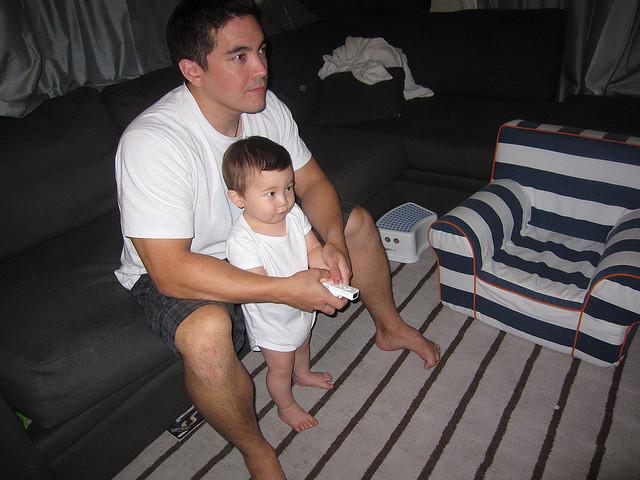What is the man and kid doing?
Keep it brief. Gaming. Is the chair wooden?
Write a very short answer. No. Is this child wearing a cap?
Be succinct. No. What are the baby and the man doing?
Write a very short answer. Playing wii. Are these people getting exercise while playing this video game?
Quick response, please. No. Is the rug striped?
Answer briefly. Yes. What does the man have in his left hand?
Write a very short answer. Controller. What are they sitting on?
Write a very short answer. Couch. Is the baby playing WII?
Short answer required. Yes. What is the person doing?
Give a very brief answer. Playing wii. Why are her arms outflung?
Write a very short answer. Playing game. Does the man have a shirt on?
Keep it brief. Yes. What is the man sitting on?
Answer briefly. Couch. What is in the man's hands?
Answer briefly. Wii remote. 